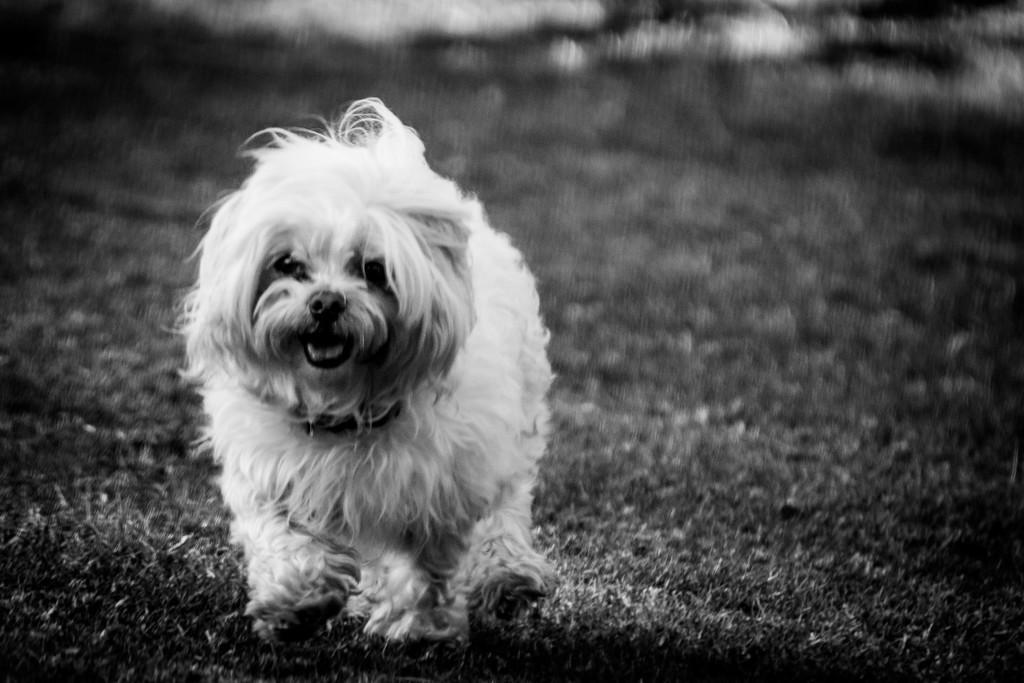What type of animal is present in the image? There is a dog in the image. What color scheme is used in the image? The image is black and white in color. Where is the rock that the dog is pushing in the image? There is no rock present in the image, and the dog is not pushing anything. 